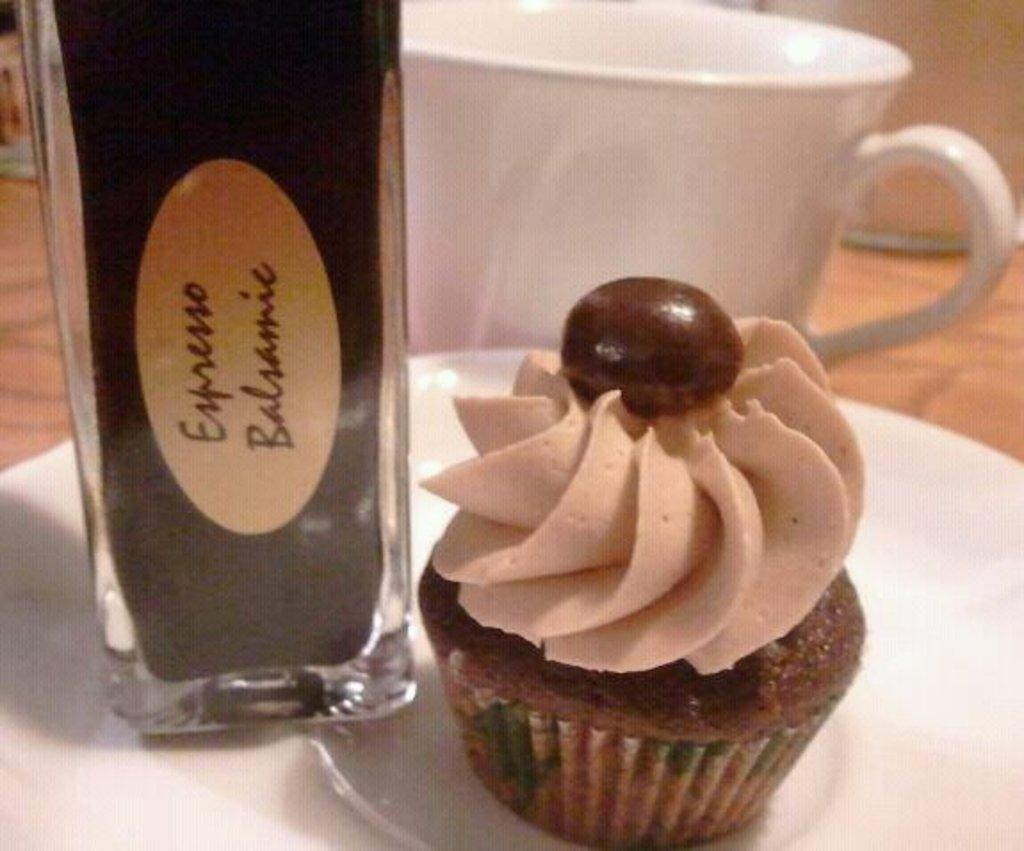<image>
Give a short and clear explanation of the subsequent image. A container of espresso flavored balsamic is next to a cupcake. 